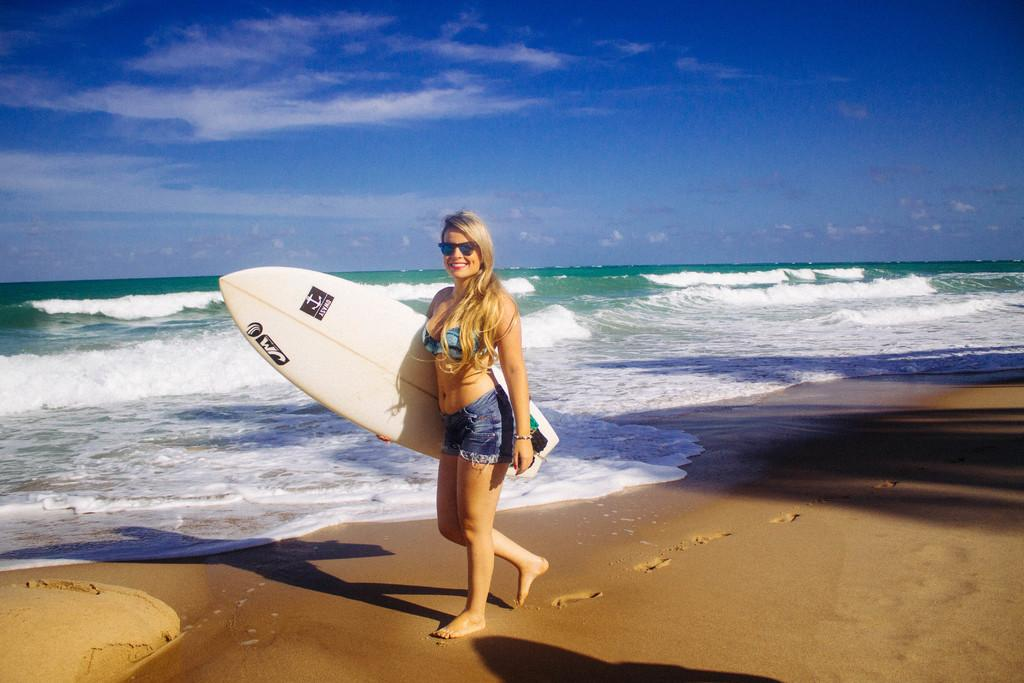What is the main subject of the image? There is a person in the image. What is the person holding in the image? The person is holding a surfing board. What type of environment is visible in the image? There is water visible in the image. What is visible in the background of the image? The sky is visible in the background of the image. What type of insect can be seen crawling on the person's scale in the image? There is no insect or scale present in the image. 